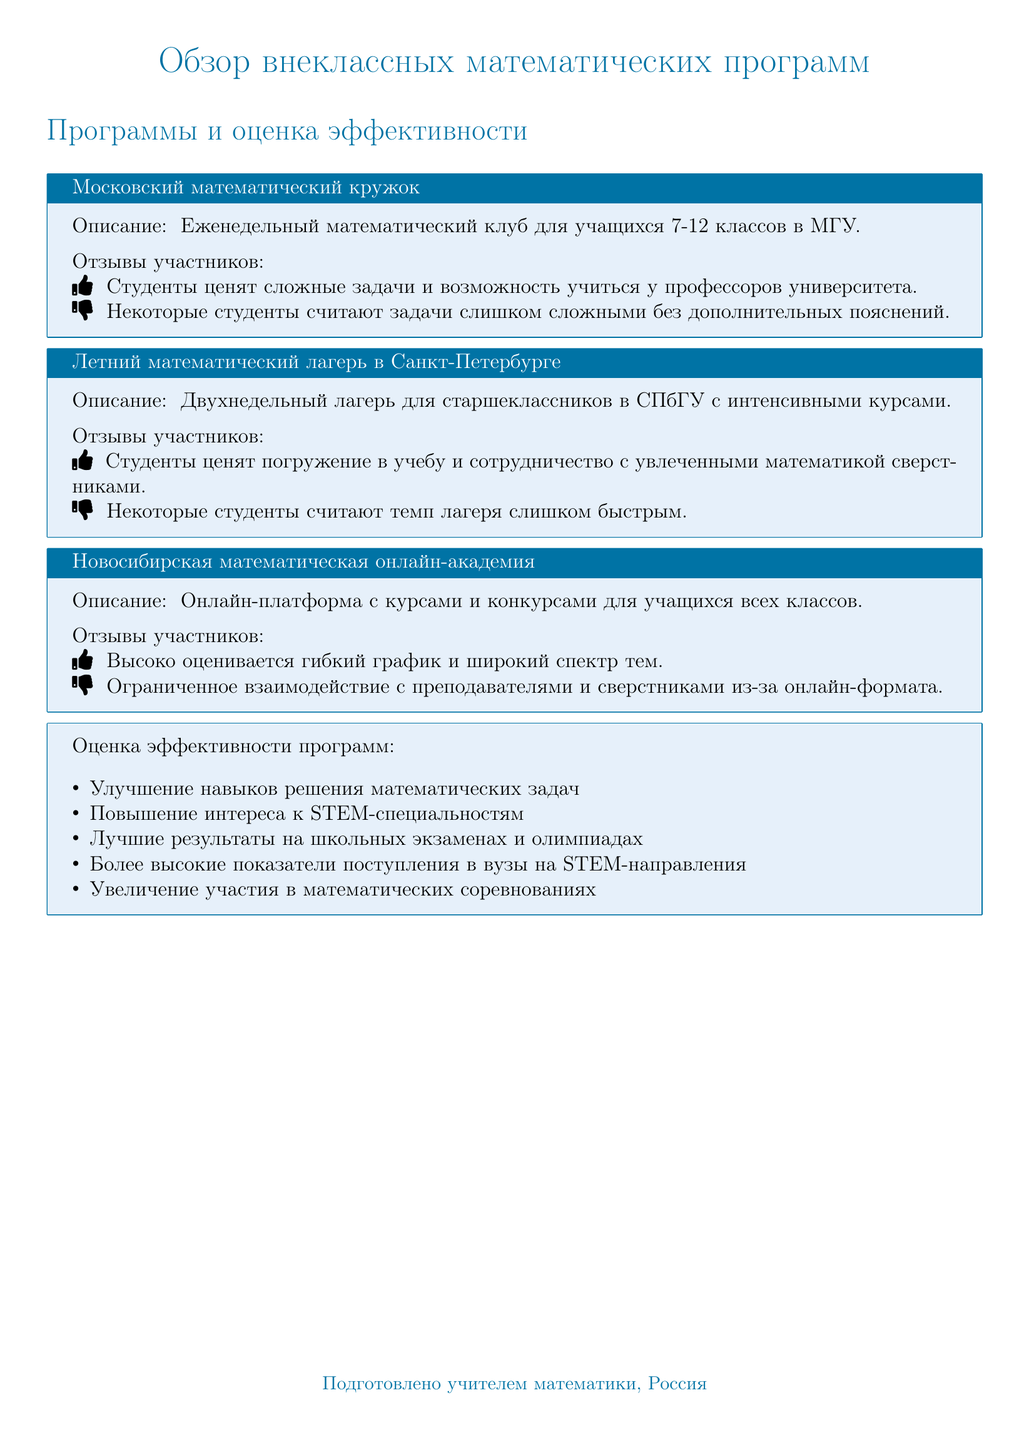Какое учреждение проводит Московский математический кружок? Математический кружок проходит в МГУ, как указано в описании программы.
Answer: МГУ Какова продолжительность летнего математического лагеря? Летний математический лагерь длится два недели, что также указано в описании программы.
Answer: Две недели Что студенты ценят в Новосибирской математической онлайн-академии? Студенты высоко оценивают гибкий график и широкий спектр тем, что упоминается в отзывах участников.
Answer: Гибкий график и широкий спектр тем Что студенты считают слишком быстрым в летнем лагере? В отзывах участников указано, что некоторые студенты считают темп лагеря слишком быстрым.
Answer: Темп лагеря Какие навыки улучшаются после участия в математических программах? В оценке эффективности указано, что улучшаются навыки решения математических задач.
Answer: Навыки решения математических задач Какой тип обратной связи представлен в документе? Документ содержит отзывы участников о разных программах, описывая положительные и отрицательные аспекты.
Answer: Отзывы участников Каковы ожидаемые результаты участия в программах? В разделе оценки эффективности указаны достижения, такие как лучшие результаты на экзаменах.
Answer: Лучшие результаты на школьных экзаменах Какое учреждение отвечает за летний математический лагерь? Летний математический лагерь проводит СПбГУ, как указано в описании программы.
Answer: СПбГУ 